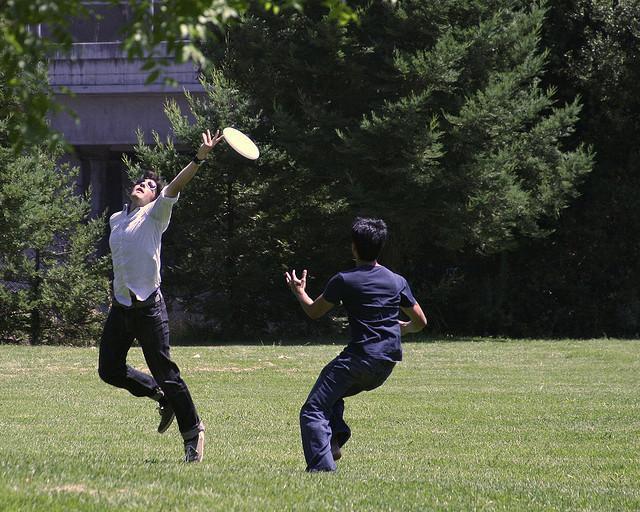How many people are there?
Give a very brief answer. 2. How many people are in the picture?
Give a very brief answer. 2. How many orange things?
Give a very brief answer. 0. 